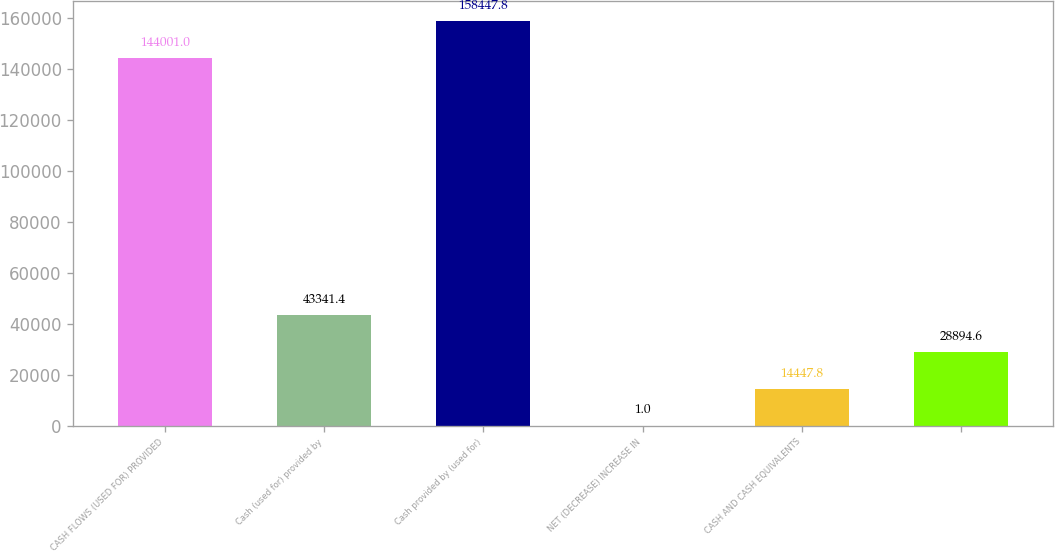<chart> <loc_0><loc_0><loc_500><loc_500><bar_chart><fcel>CASH FLOWS (USED FOR) PROVIDED<fcel>Cash (used for) provided by<fcel>Cash provided by (used for)<fcel>NET (DECREASE) INCREASE IN<fcel>CASH AND CASH EQUIVALENTS<fcel>Unnamed: 5<nl><fcel>144001<fcel>43341.4<fcel>158448<fcel>1<fcel>14447.8<fcel>28894.6<nl></chart> 